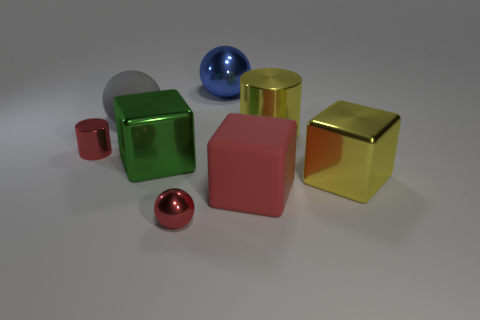Are there more red cylinders to the right of the green object than small shiny objects?
Keep it short and to the point. No. There is a small thing behind the big red rubber thing; what shape is it?
Offer a very short reply. Cylinder. What number of other things are the same shape as the red matte thing?
Your response must be concise. 2. Does the cylinder on the left side of the blue object have the same material as the gray object?
Keep it short and to the point. No. Are there an equal number of rubber things that are to the left of the red block and green objects behind the large blue sphere?
Your answer should be very brief. No. There is a metallic cube on the left side of the large yellow metal cylinder; what is its size?
Make the answer very short. Large. Is there a tiny purple cube made of the same material as the big blue object?
Your answer should be compact. No. There is a rubber object behind the green object; does it have the same color as the tiny metal cylinder?
Keep it short and to the point. No. Are there the same number of yellow metal cylinders that are right of the large gray rubber sphere and large brown rubber cubes?
Keep it short and to the point. No. Are there any small things of the same color as the rubber cube?
Offer a very short reply. Yes. 